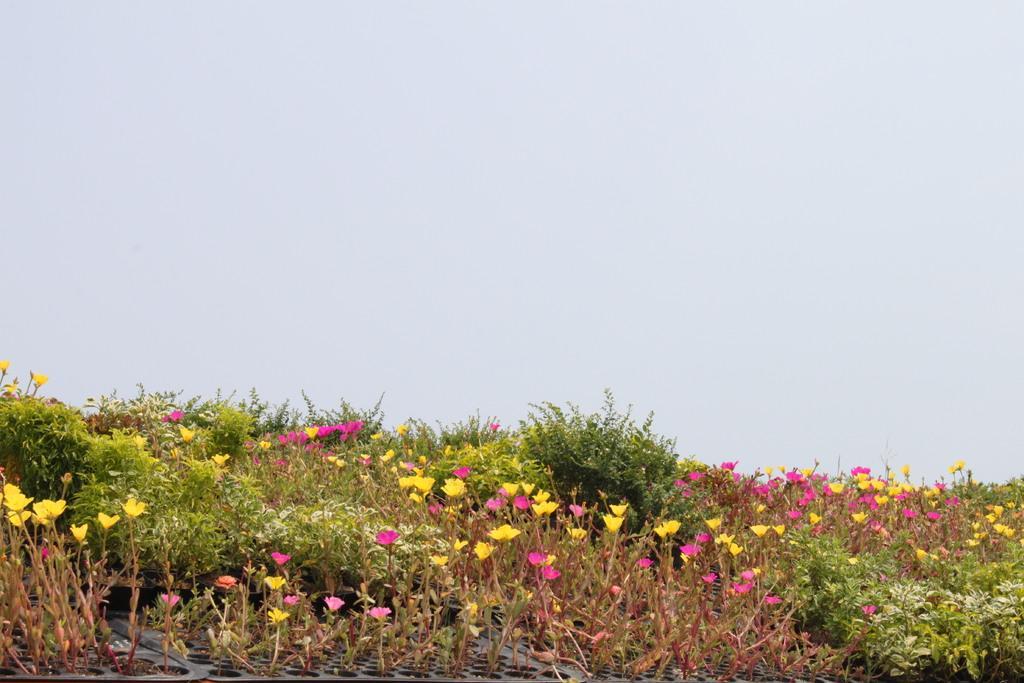Can you describe this image briefly? In this image there are few plants having flowers. Few plants are kept on the tray. Top of the image there is sky. 